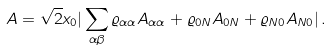Convert formula to latex. <formula><loc_0><loc_0><loc_500><loc_500>A = \sqrt { 2 } x _ { 0 } | \sum _ { \alpha \beta } \varrho _ { \alpha \alpha } A _ { \alpha \alpha } + \varrho _ { 0 N } A _ { 0 N } + \varrho _ { N 0 } A _ { N 0 } | \, .</formula> 